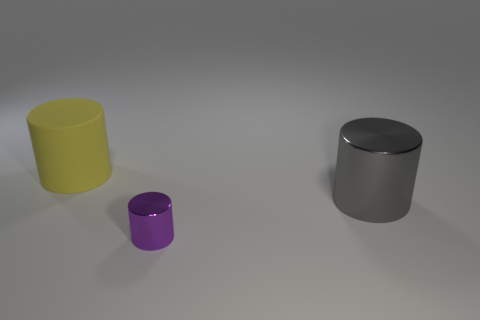Add 2 tiny purple metallic cylinders. How many objects exist? 5 Subtract all purple metal cylinders. Subtract all large gray blocks. How many objects are left? 2 Add 3 big gray cylinders. How many big gray cylinders are left? 4 Add 2 large gray metallic cylinders. How many large gray metallic cylinders exist? 3 Subtract 0 red cubes. How many objects are left? 3 